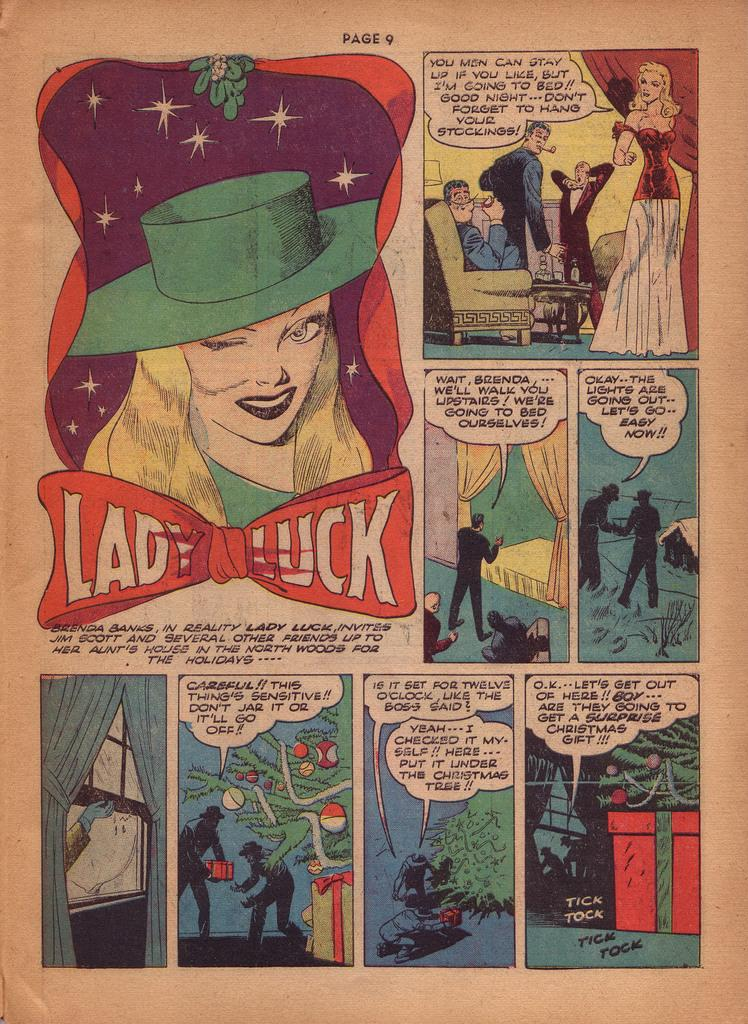<image>
Relay a brief, clear account of the picture shown. One of the panels of a slightly faded comic strip includes a woman and the words Lady Luck. 